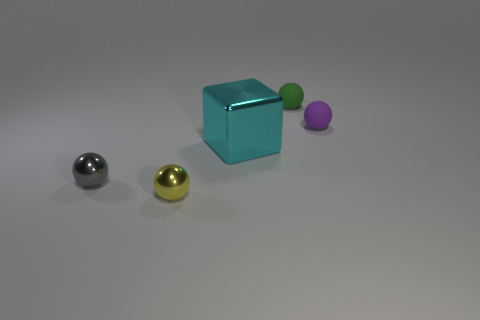Subtract all small green balls. How many balls are left? 3 Add 4 shiny balls. How many objects exist? 9 Subtract all green spheres. How many spheres are left? 3 Subtract all blocks. How many objects are left? 4 Subtract all red spheres. Subtract all purple cubes. How many spheres are left? 4 Subtract all small yellow objects. Subtract all big things. How many objects are left? 3 Add 4 big cyan metallic things. How many big cyan metallic things are left? 5 Add 3 green matte balls. How many green matte balls exist? 4 Subtract 0 red cylinders. How many objects are left? 5 